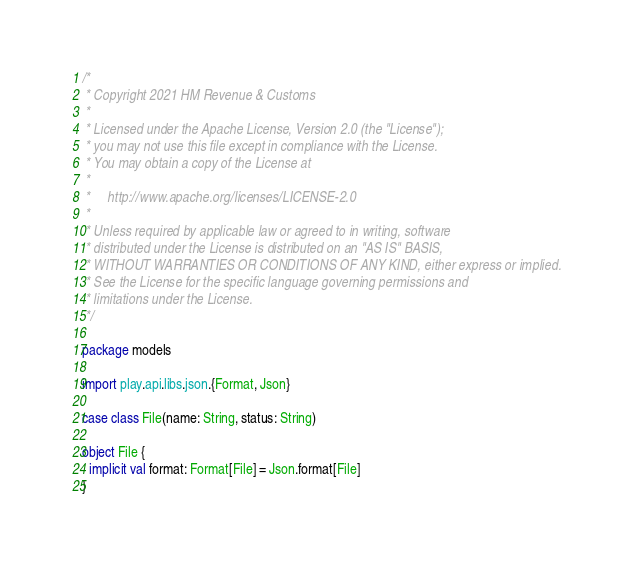Convert code to text. <code><loc_0><loc_0><loc_500><loc_500><_Scala_>/*
 * Copyright 2021 HM Revenue & Customs
 *
 * Licensed under the Apache License, Version 2.0 (the "License");
 * you may not use this file except in compliance with the License.
 * You may obtain a copy of the License at
 *
 *     http://www.apache.org/licenses/LICENSE-2.0
 *
 * Unless required by applicable law or agreed to in writing, software
 * distributed under the License is distributed on an "AS IS" BASIS,
 * WITHOUT WARRANTIES OR CONDITIONS OF ANY KIND, either express or implied.
 * See the License for the specific language governing permissions and
 * limitations under the License.
 */

package models

import play.api.libs.json.{Format, Json}

case class File(name: String, status: String)

object File {
  implicit val format: Format[File] = Json.format[File]
}
</code> 